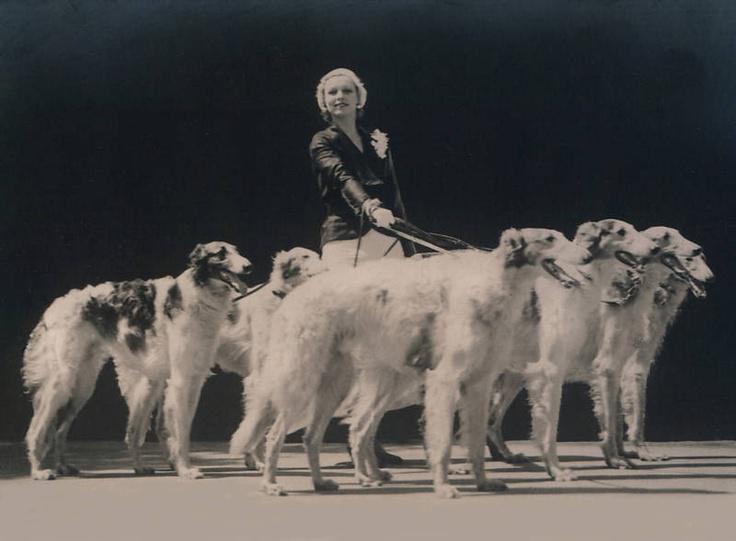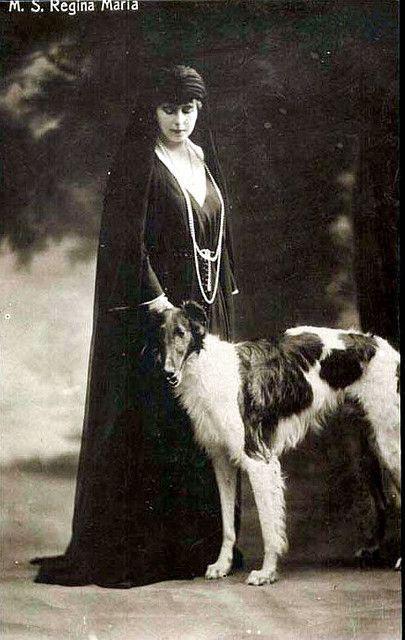The first image is the image on the left, the second image is the image on the right. Assess this claim about the two images: "A woman is standing with a single dog.". Correct or not? Answer yes or no. Yes. The first image is the image on the left, the second image is the image on the right. Given the left and right images, does the statement "An image shows a lady in a dark gown standing behind one hound." hold true? Answer yes or no. Yes. 